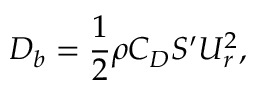Convert formula to latex. <formula><loc_0><loc_0><loc_500><loc_500>D _ { b } = \frac { 1 } { 2 } \rho C _ { D } S ^ { \prime } U _ { r } ^ { 2 } ,</formula> 